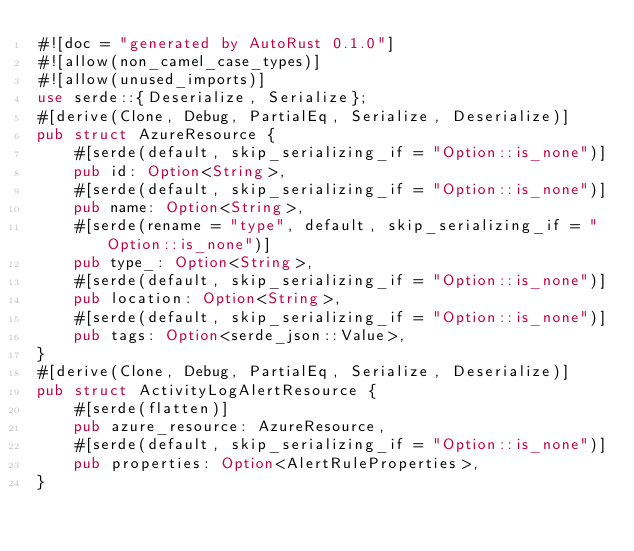<code> <loc_0><loc_0><loc_500><loc_500><_Rust_>#![doc = "generated by AutoRust 0.1.0"]
#![allow(non_camel_case_types)]
#![allow(unused_imports)]
use serde::{Deserialize, Serialize};
#[derive(Clone, Debug, PartialEq, Serialize, Deserialize)]
pub struct AzureResource {
    #[serde(default, skip_serializing_if = "Option::is_none")]
    pub id: Option<String>,
    #[serde(default, skip_serializing_if = "Option::is_none")]
    pub name: Option<String>,
    #[serde(rename = "type", default, skip_serializing_if = "Option::is_none")]
    pub type_: Option<String>,
    #[serde(default, skip_serializing_if = "Option::is_none")]
    pub location: Option<String>,
    #[serde(default, skip_serializing_if = "Option::is_none")]
    pub tags: Option<serde_json::Value>,
}
#[derive(Clone, Debug, PartialEq, Serialize, Deserialize)]
pub struct ActivityLogAlertResource {
    #[serde(flatten)]
    pub azure_resource: AzureResource,
    #[serde(default, skip_serializing_if = "Option::is_none")]
    pub properties: Option<AlertRuleProperties>,
}</code> 